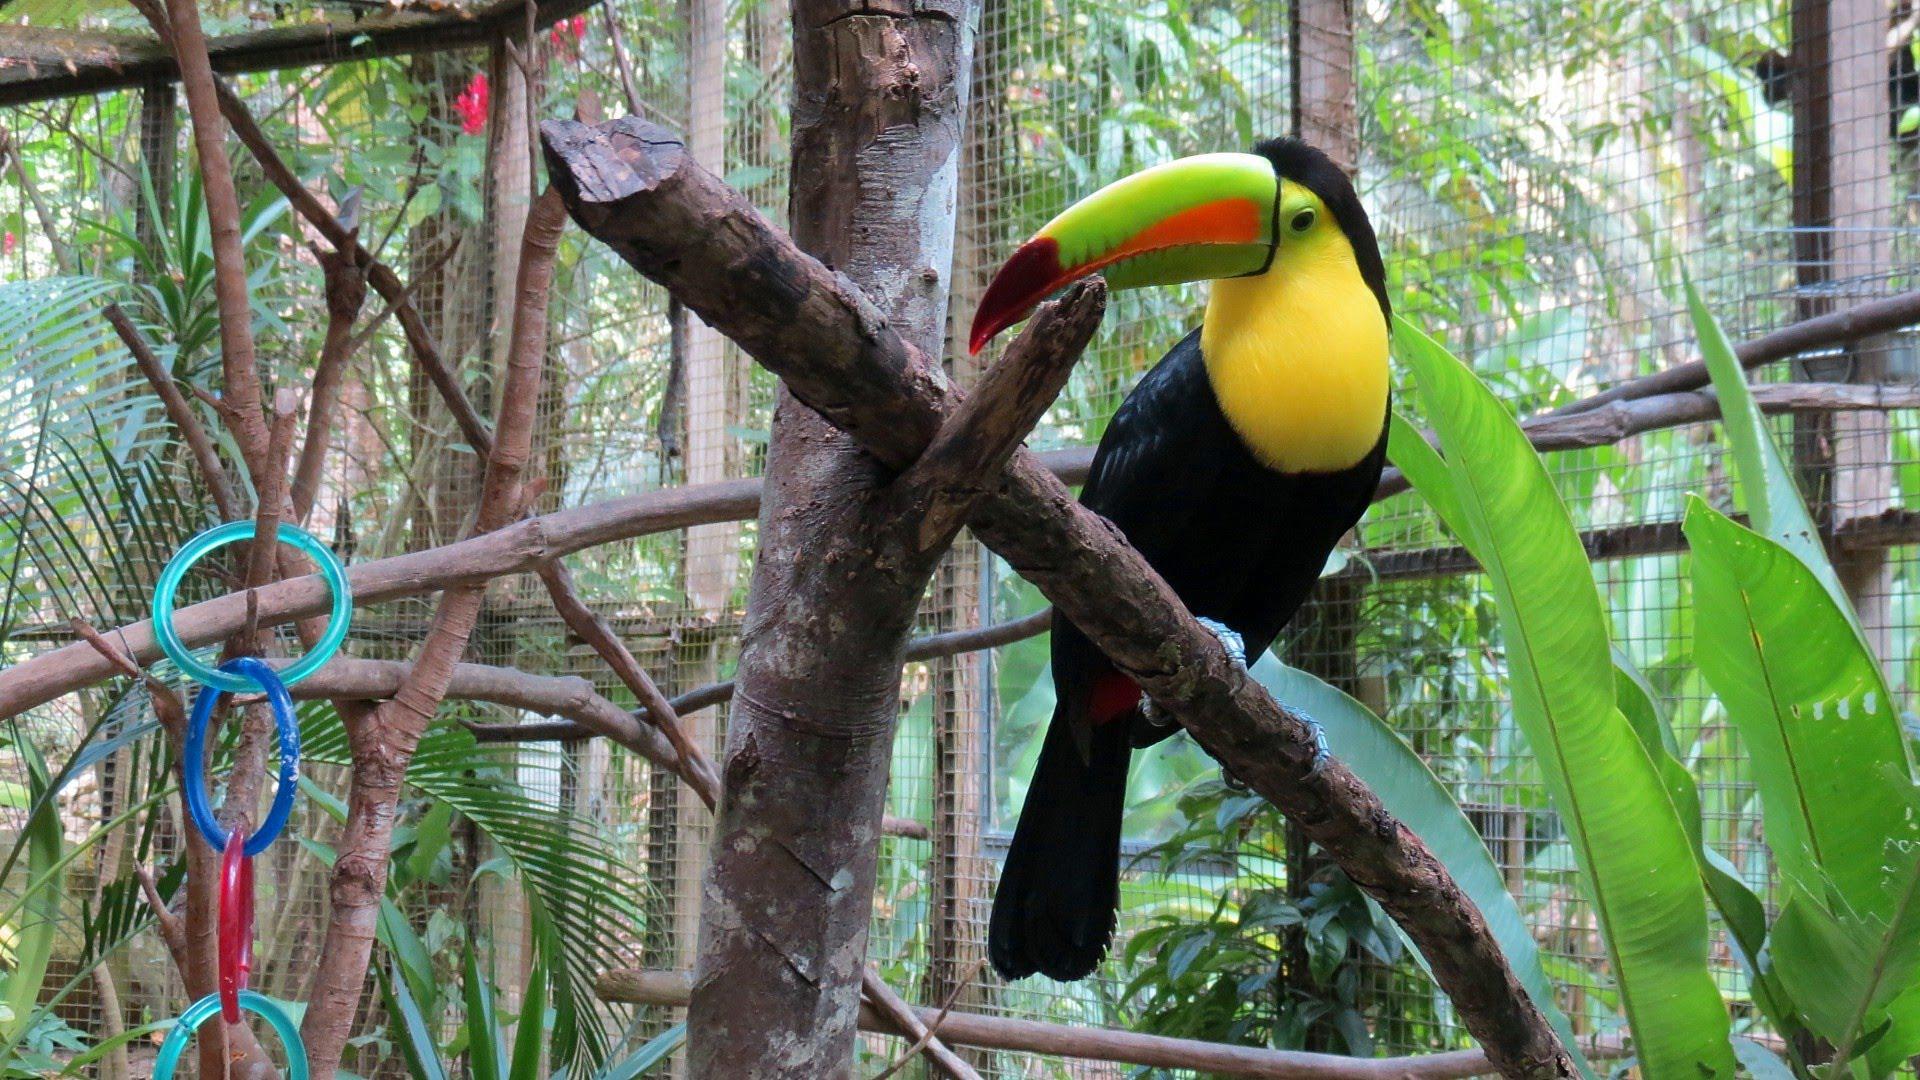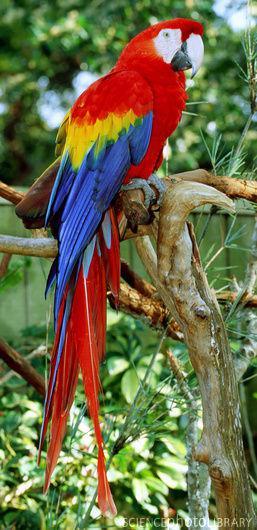The first image is the image on the left, the second image is the image on the right. For the images shown, is this caption "No image contains more than two parrot-type birds, and each image contains exactly one red-headed bird." true? Answer yes or no. No. The first image is the image on the left, the second image is the image on the right. Given the left and right images, does the statement "There is one predominately red bird perched in the image on the left." hold true? Answer yes or no. No. 